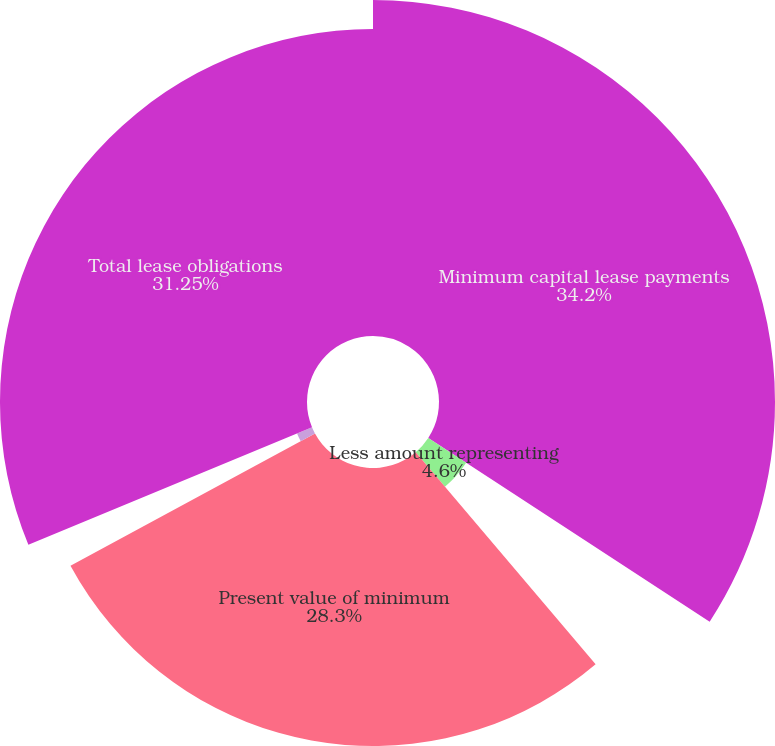Convert chart. <chart><loc_0><loc_0><loc_500><loc_500><pie_chart><fcel>Minimum capital lease payments<fcel>Less amount representing<fcel>Present value of minimum<fcel>Operating leases<fcel>Total lease obligations<nl><fcel>34.2%<fcel>4.6%<fcel>28.3%<fcel>1.65%<fcel>31.25%<nl></chart> 